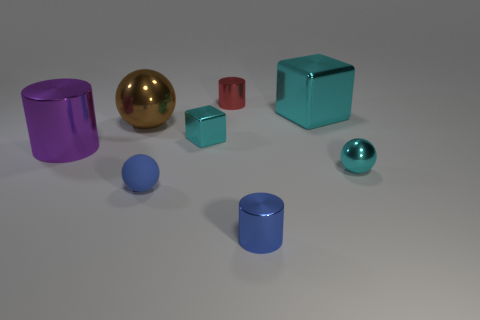Subtract all large shiny cylinders. How many cylinders are left? 2 Subtract all gray cylinders. Subtract all purple cubes. How many cylinders are left? 3 Add 2 big rubber balls. How many objects exist? 10 Subtract all cubes. How many objects are left? 6 Subtract 1 red cylinders. How many objects are left? 7 Subtract all large purple shiny cylinders. Subtract all blue metal cylinders. How many objects are left? 6 Add 7 big brown shiny balls. How many big brown shiny balls are left? 8 Add 8 large brown balls. How many large brown balls exist? 9 